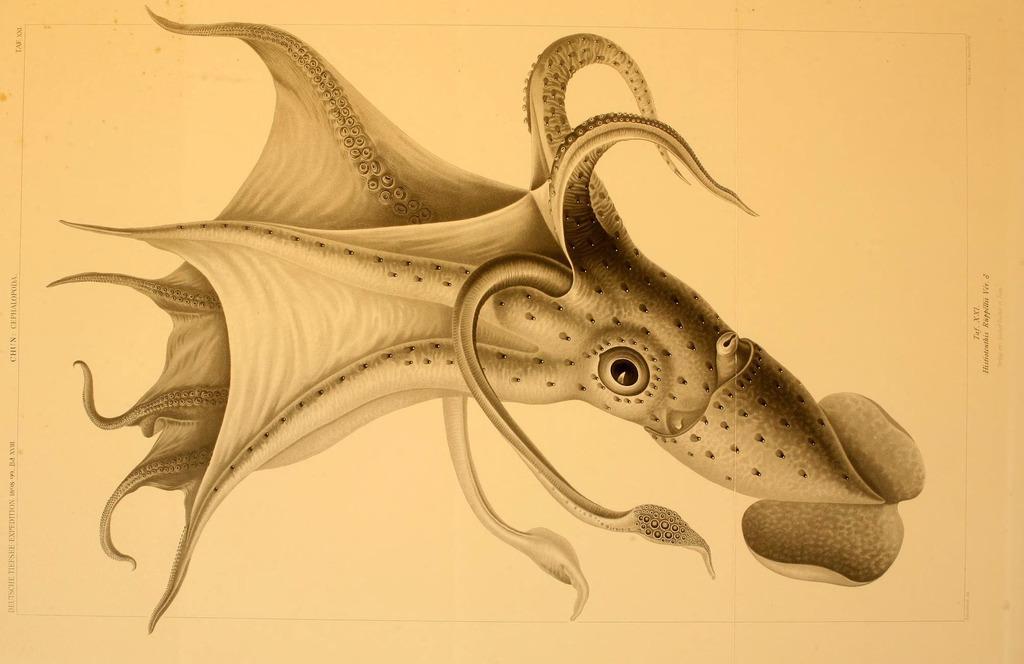Describe this image in one or two sentences. In this image we can see the picture of a octopus. 